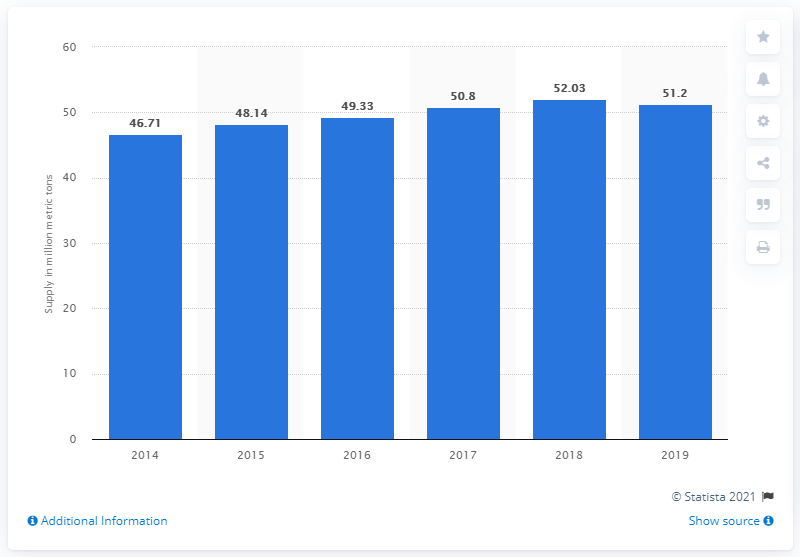Specify some key components in this picture. The estimated global supply of phosphoric acid fertilizers in 2014 was 46.71 million metric tons. 